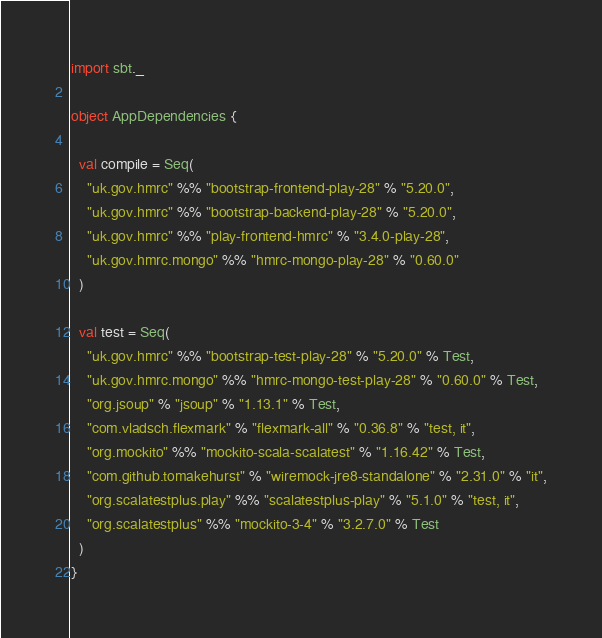<code> <loc_0><loc_0><loc_500><loc_500><_Scala_>import sbt._

object AppDependencies {

  val compile = Seq(
    "uk.gov.hmrc" %% "bootstrap-frontend-play-28" % "5.20.0",
    "uk.gov.hmrc" %% "bootstrap-backend-play-28" % "5.20.0",
    "uk.gov.hmrc" %% "play-frontend-hmrc" % "3.4.0-play-28",
    "uk.gov.hmrc.mongo" %% "hmrc-mongo-play-28" % "0.60.0"
  )

  val test = Seq(
    "uk.gov.hmrc" %% "bootstrap-test-play-28" % "5.20.0" % Test,
    "uk.gov.hmrc.mongo" %% "hmrc-mongo-test-play-28" % "0.60.0" % Test,
    "org.jsoup" % "jsoup" % "1.13.1" % Test,
    "com.vladsch.flexmark" % "flexmark-all" % "0.36.8" % "test, it",
    "org.mockito" %% "mockito-scala-scalatest" % "1.16.42" % Test,
    "com.github.tomakehurst" % "wiremock-jre8-standalone" % "2.31.0" % "it",
    "org.scalatestplus.play" %% "scalatestplus-play" % "5.1.0" % "test, it",
    "org.scalatestplus" %% "mockito-3-4" % "3.2.7.0" % Test
  )
}
</code> 